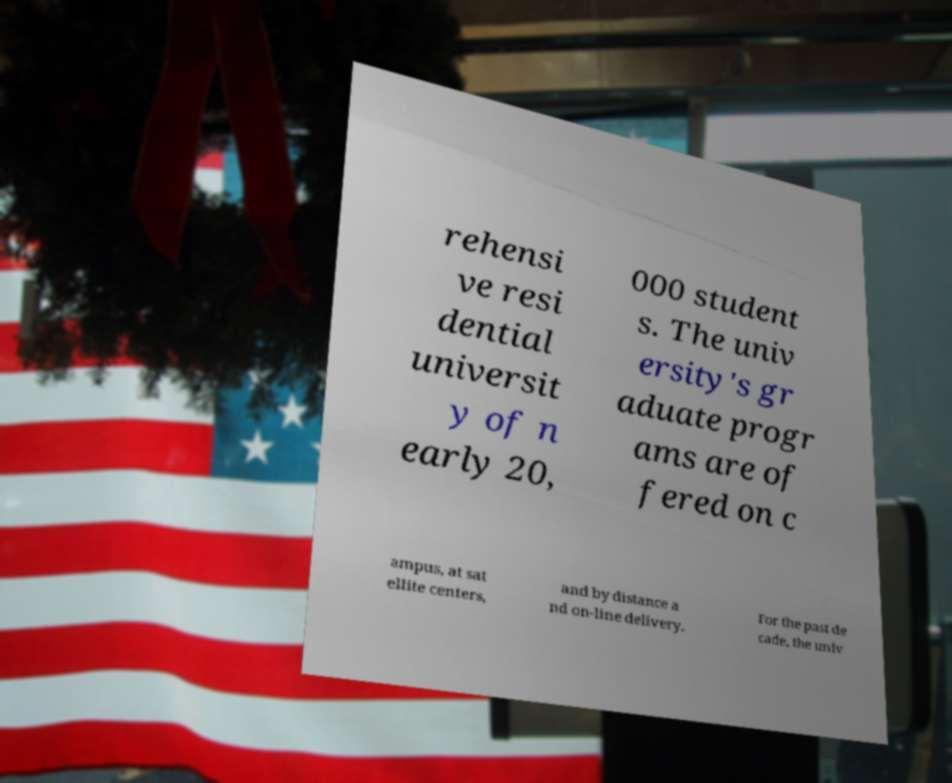What messages or text are displayed in this image? I need them in a readable, typed format. rehensi ve resi dential universit y of n early 20, 000 student s. The univ ersity's gr aduate progr ams are of fered on c ampus, at sat ellite centers, and by distance a nd on-line delivery. For the past de cade, the univ 